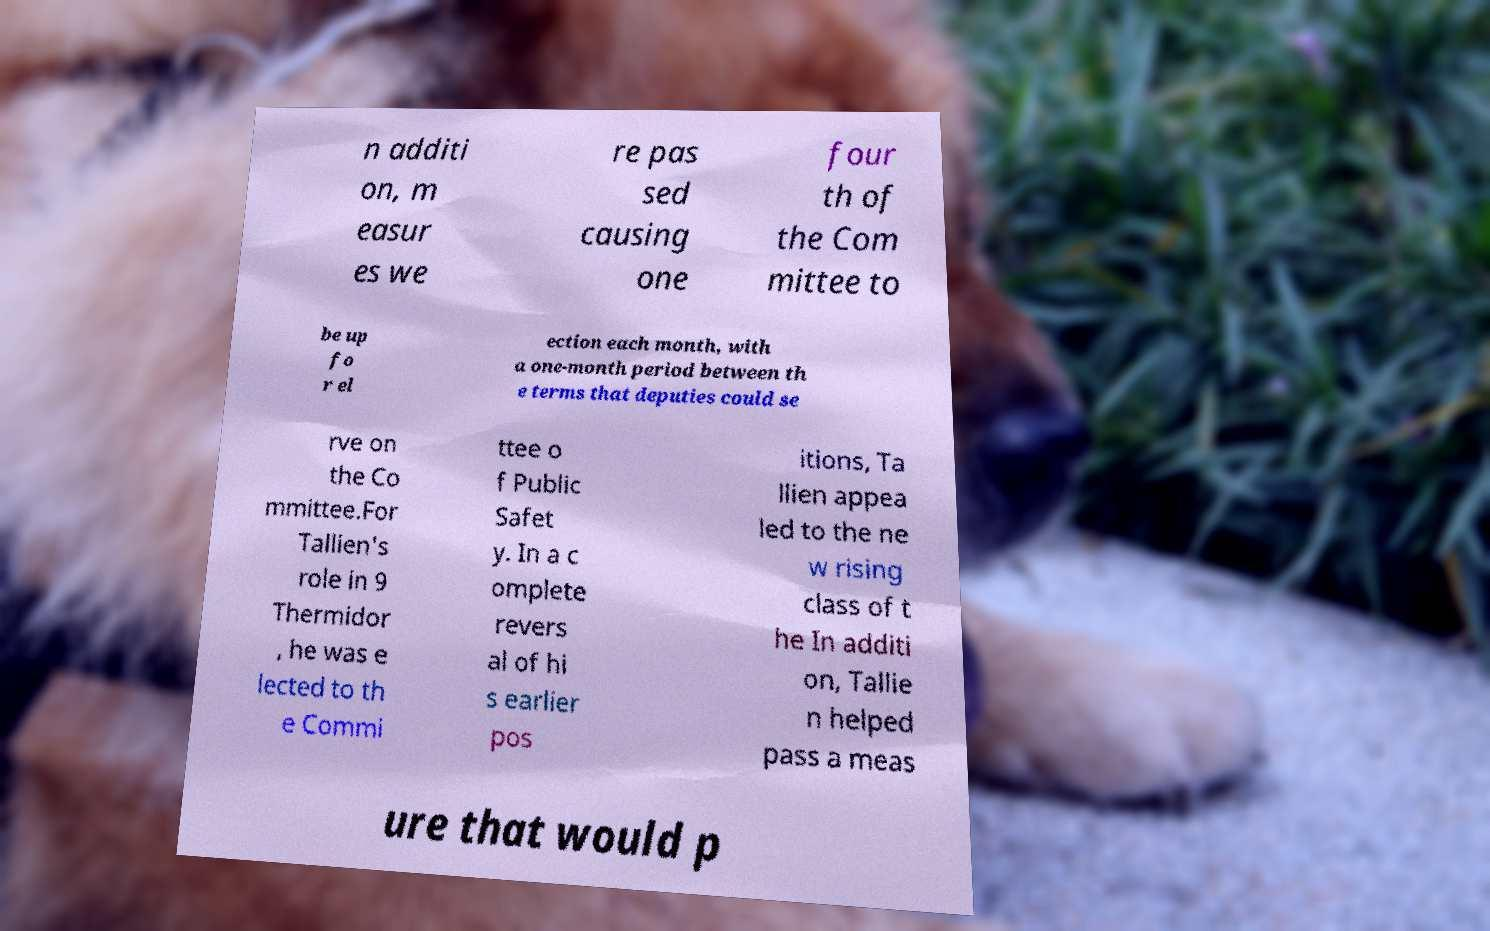Please read and relay the text visible in this image. What does it say? n additi on, m easur es we re pas sed causing one four th of the Com mittee to be up fo r el ection each month, with a one-month period between th e terms that deputies could se rve on the Co mmittee.For Tallien's role in 9 Thermidor , he was e lected to th e Commi ttee o f Public Safet y. In a c omplete revers al of hi s earlier pos itions, Ta llien appea led to the ne w rising class of t he In additi on, Tallie n helped pass a meas ure that would p 